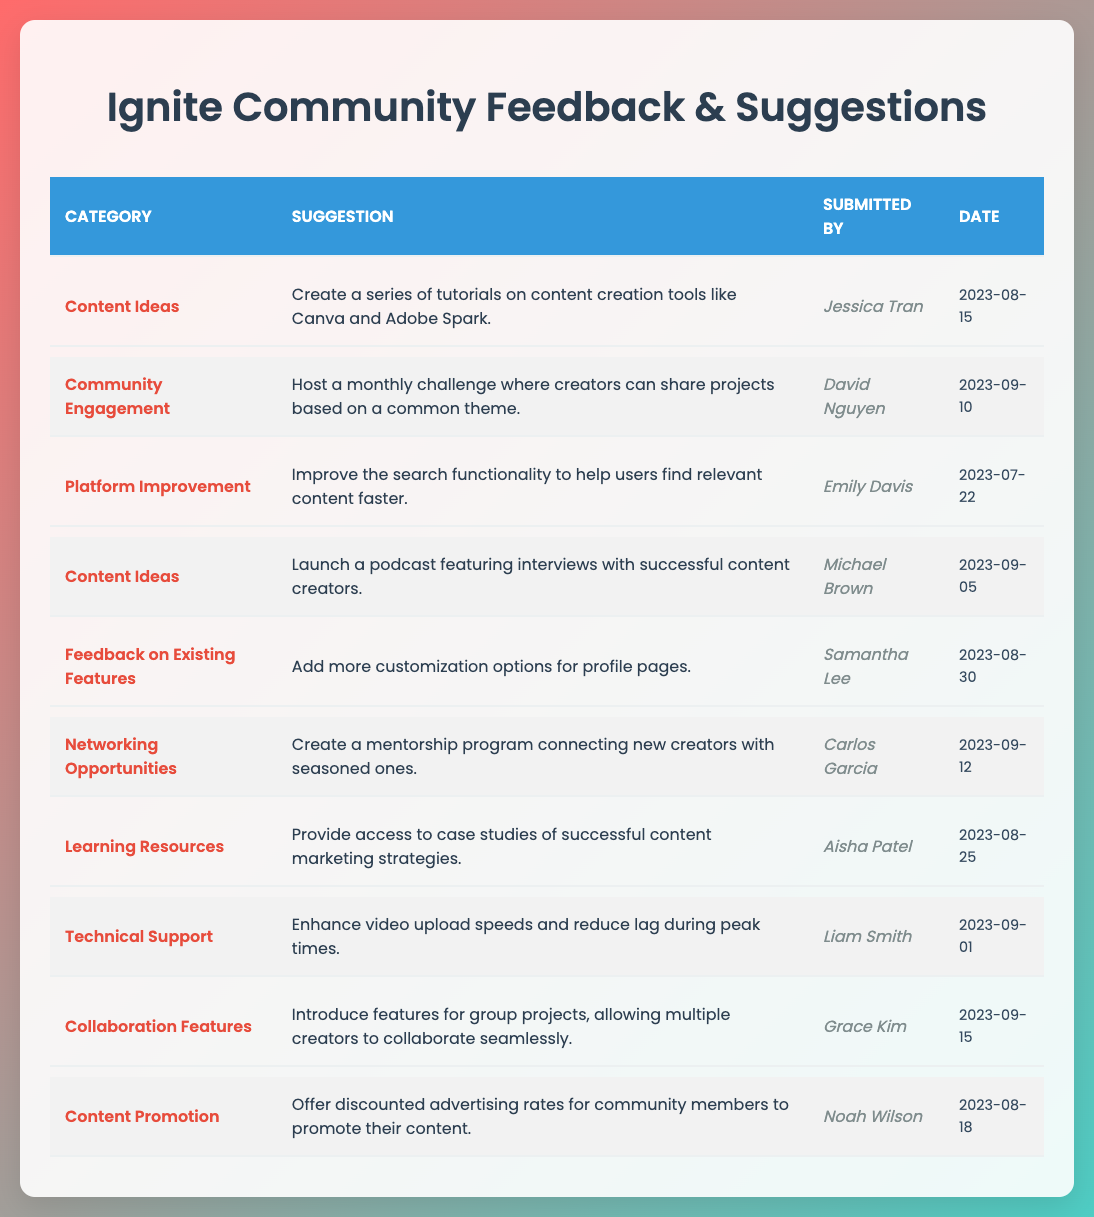What is the suggestion submitted by Jessica Tran? The table indicates Jessica Tran submitted the suggestion to "Create a series of tutorials on content creation tools like Canva and Adobe Spark."
Answer: Create a series of tutorials on content creation tools like Canva and Adobe Spark How many suggestions are categorized under "Content Ideas"? There are two suggestions under the "Content Ideas" category: one from Jessica Tran and another from Michael Brown, which totals to 2.
Answer: 2 Which suggestion was submitted most recently and what is its category? The most recent suggestion is from Grace Kim, submitted on "2023-09-15," categorized under "Collaboration Features."
Answer: Collaboration Features, Introduce features for group projects, allowing multiple creators to collaborate seamlessly Is there a suggestion for improving technical support? The table shows a suggestion from Liam Smith about enhancing video upload speeds and reducing lag during peak times, confirming there is a technical support suggestion.
Answer: Yes What is the overall total number of unique categories mentioned in the suggestions? The unique categories are: Content Ideas, Community Engagement, Platform Improvement, Feedback on Existing Features, Networking Opportunities, Learning Resources, Technical Support, Collaboration Features, and Content Promotion. This makes a total of 9 unique categories.
Answer: 9 Which suggestion relates to networking opportunities, and who submitted it? The suggestion that relates to networking opportunities is about creating a mentorship program connecting new creators with seasoned ones and was submitted by Carlos Garcia.
Answer: Create a mentorship program connecting new creators with seasoned ones, submitted by Carlos Garcia Which category has the least number of suggestions listed? The table shows multiple categories, but Learning Resources and Content Promotion have only one suggestion each, making them the categories with the least number of suggestions.
Answer: Learning Resources and Content Promotion (both have 1 suggestion each) What are the dates of the suggestions submitted in August? The suggestions submitted in August come from Jessica Tran (2023-08-15), Samantha Lee (2023-08-30), and Noah Wilson (2023-08-18). Thus, the notable dates in August are 15th, 18th, and 30th.
Answer: 15th, 18th, and 30th August 